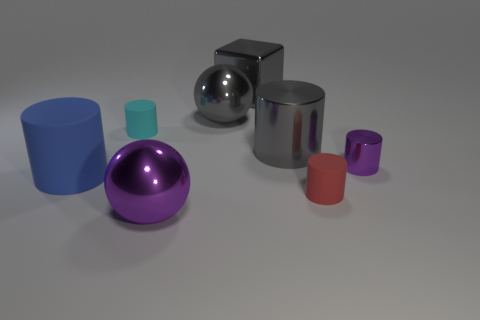Subtract all cyan cubes. Subtract all gray spheres. How many cubes are left? 1 Add 1 large gray objects. How many objects exist? 9 Subtract all blocks. How many objects are left? 7 Add 5 big blue cylinders. How many big blue cylinders are left? 6 Add 3 small cyan rubber spheres. How many small cyan rubber spheres exist? 3 Subtract 0 cyan spheres. How many objects are left? 8 Subtract all large objects. Subtract all tiny green blocks. How many objects are left? 3 